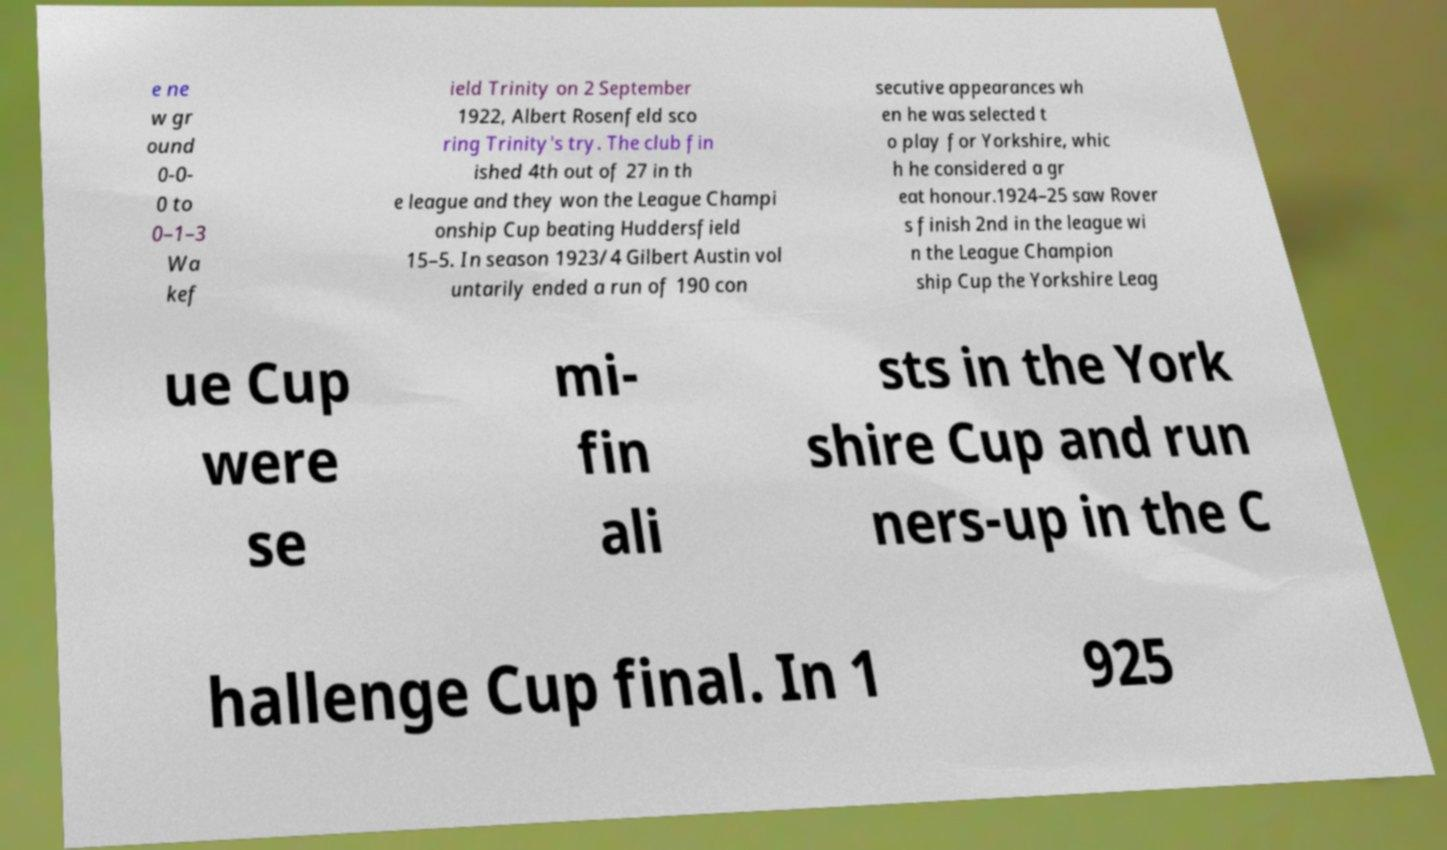Can you accurately transcribe the text from the provided image for me? e ne w gr ound 0-0- 0 to 0–1–3 Wa kef ield Trinity on 2 September 1922, Albert Rosenfeld sco ring Trinity's try. The club fin ished 4th out of 27 in th e league and they won the League Champi onship Cup beating Huddersfield 15–5. In season 1923/4 Gilbert Austin vol untarily ended a run of 190 con secutive appearances wh en he was selected t o play for Yorkshire, whic h he considered a gr eat honour.1924–25 saw Rover s finish 2nd in the league wi n the League Champion ship Cup the Yorkshire Leag ue Cup were se mi- fin ali sts in the York shire Cup and run ners-up in the C hallenge Cup final. In 1 925 